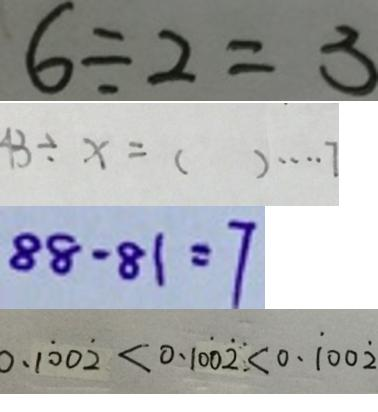Convert formula to latex. <formula><loc_0><loc_0><loc_500><loc_500>6 \div 2 = 3 
 4 3 \div x = ( ) \cdots 7 
 8 8 - 8 1 = 7 
 0 . 1 \dot { 0 } 0 \dot { 2 } < 0 . 1 0 \dot { 0 } \dot { 2 } < 0 . \dot { 1 } 0 0 \dot { 2 }</formula> 